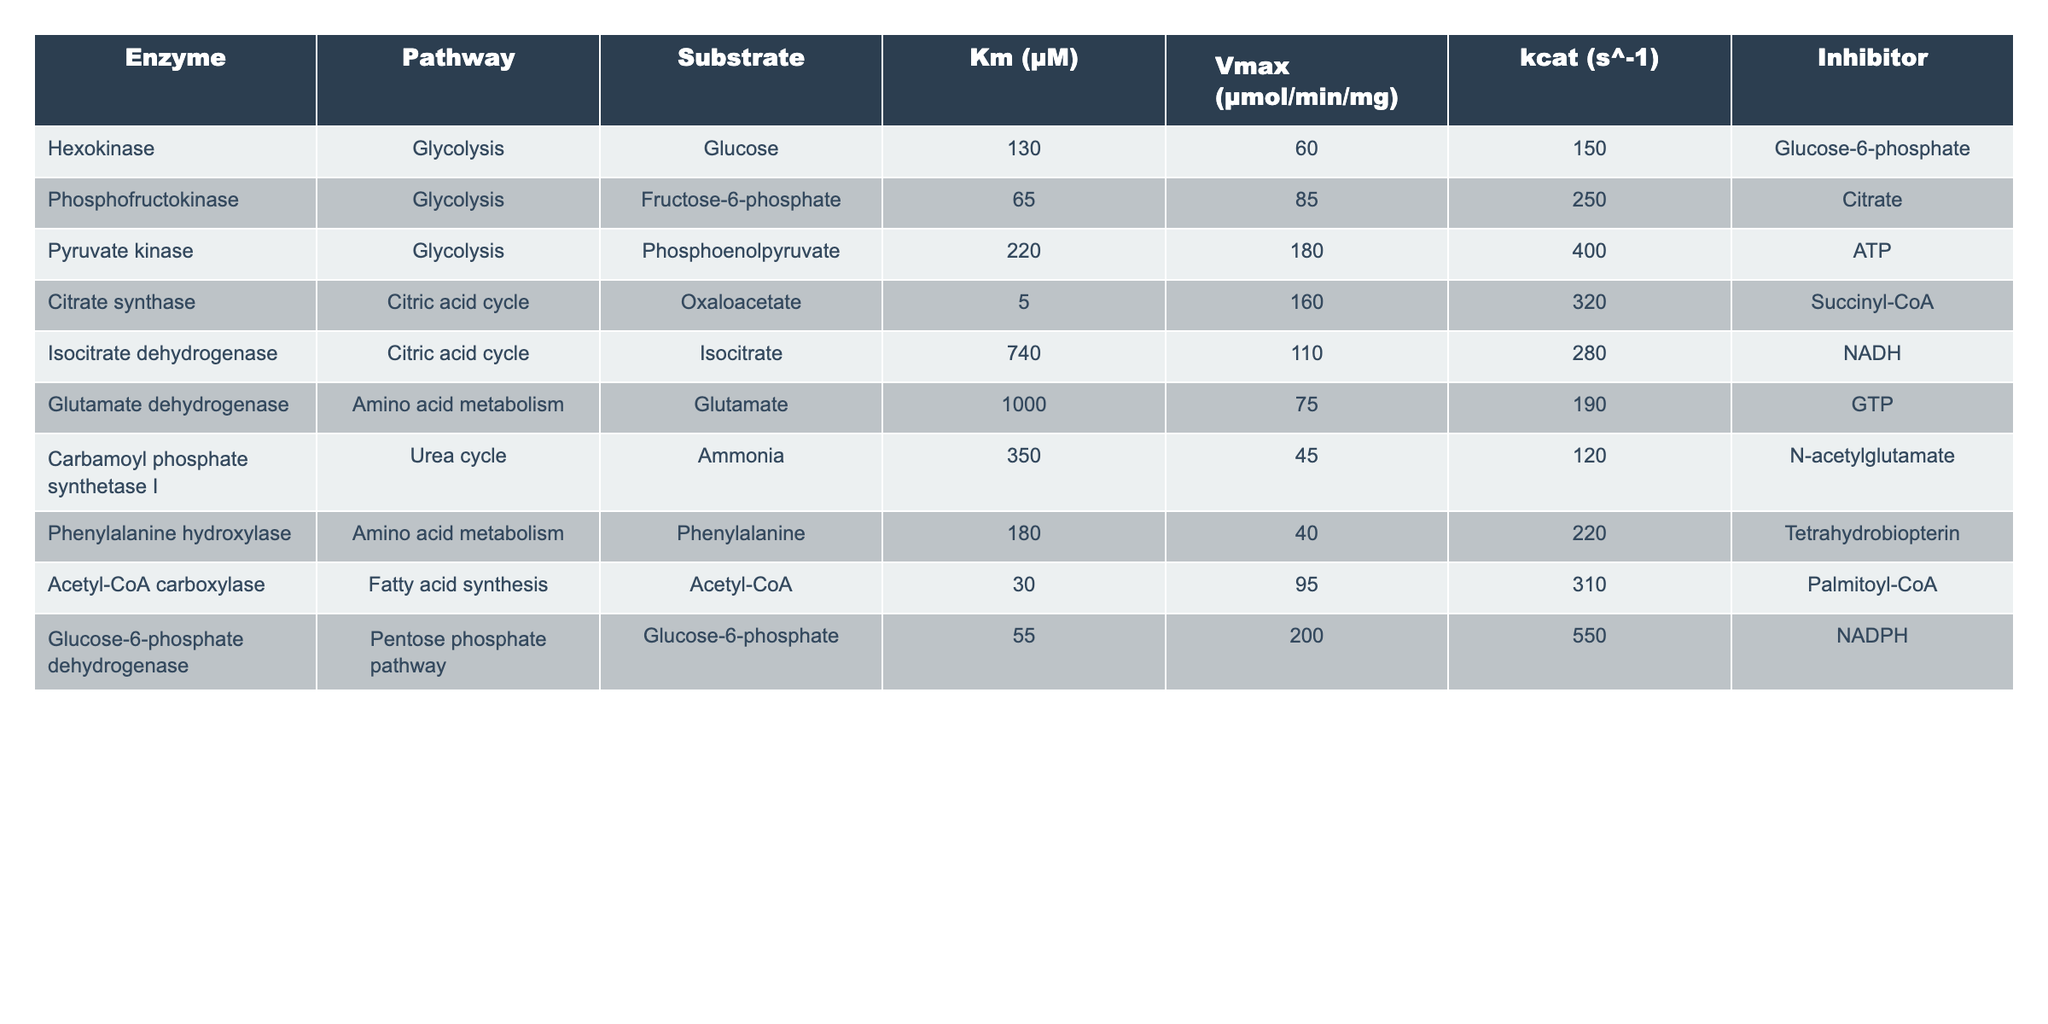What is the Km value for Citrate synthase in the Citric acid cycle? The table lists the Km value for Citrate synthase under the Citric acid cycle, which is directly provided in the relevant row of the table. The value is 5 μM.
Answer: 5 μM Which enzyme has the highest Vmax value, and what is that value? In the table, I compare the Vmax values for each enzyme listed. Pyruvate kinase shows the highest Vmax at 180 μmol/min/mg.
Answer: Pyruvate kinase; 180 μmol/min/mg Is there an enzyme in the Urea cycle? By reviewing the table, I check the pathway column for the Urea cycle. Indeed, Carbamoyl phosphate synthetase I is listed under the Urea cycle.
Answer: Yes What is the average kcat value for the enzymes involved in Glycolysis? I first list the kcat values for enzymes in Glycolysis: Hexokinase (150 s^-1), Phosphofructokinase (250 s^-1), and Pyruvate kinase (400 s^-1). Then, sum these values: 150 + 250 + 400 = 800. Finally, divide by the number of enzymes (3) to get the average: 800/3 = 266.67.
Answer: 266.67 s^-1 Does Glucose-6-phosphate act as an inhibitor for Hexokinase? I can find the relevant row for Hexokinase and observe the inhibitor listed in the table, which is Glucose-6-phosphate.
Answer: Yes What is the difference in Km values between Glutamate dehydrogenase and Phenylalanine hydroxylase? I find the Km values for both enzymes: Glutamate dehydrogenase has a Km of 1000 μM, and Phenylalanine hydroxylase has a Km of 180 μM. I calculate the difference: 1000 - 180 = 820 μM.
Answer: 820 μM Which pathway has an enzyme that has a Vmax value of 200 μmol/min/mg? I scan the table for Vmax values and find that Glucose-6-phosphate dehydrogenase, which belongs to the Pentose phosphate pathway, has a Vmax of 200 μmol/min/mg.
Answer: Pentose phosphate pathway Identify an enzyme that is inhibited by NADPH. I look at the table's inhibitor column for the enzyme listings and find Glucose-6-phosphate dehydrogenase, which is inhibited by NADPH.
Answer: Glucose-6-phosphate dehydrogenase What is the total Vmax for the enzymes in the Amino acid metabolism pathway? I identify the enzymes listed under Amino acid metabolism: Glutamate dehydrogenase (75 μmol/min/mg) and Phenylalanine hydroxylase (40 μmol/min/mg). I sum these Vmax values: 75 + 40 = 115 μmol/min/mg.
Answer: 115 μmol/min/mg 